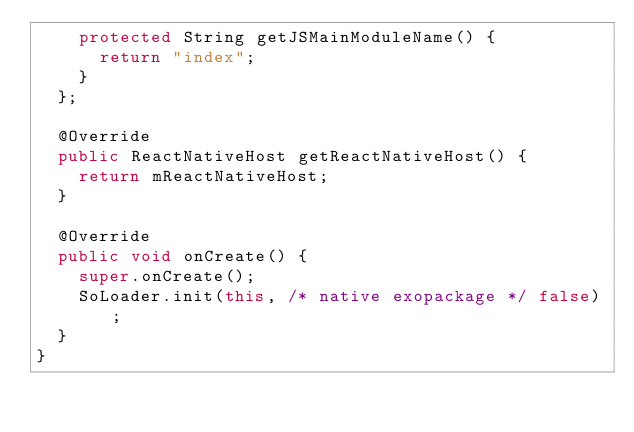<code> <loc_0><loc_0><loc_500><loc_500><_Java_>    protected String getJSMainModuleName() {
      return "index";
    }
  };

  @Override
  public ReactNativeHost getReactNativeHost() {
    return mReactNativeHost;
  }

  @Override
  public void onCreate() {
    super.onCreate();
    SoLoader.init(this, /* native exopackage */ false);
  }
}
</code> 